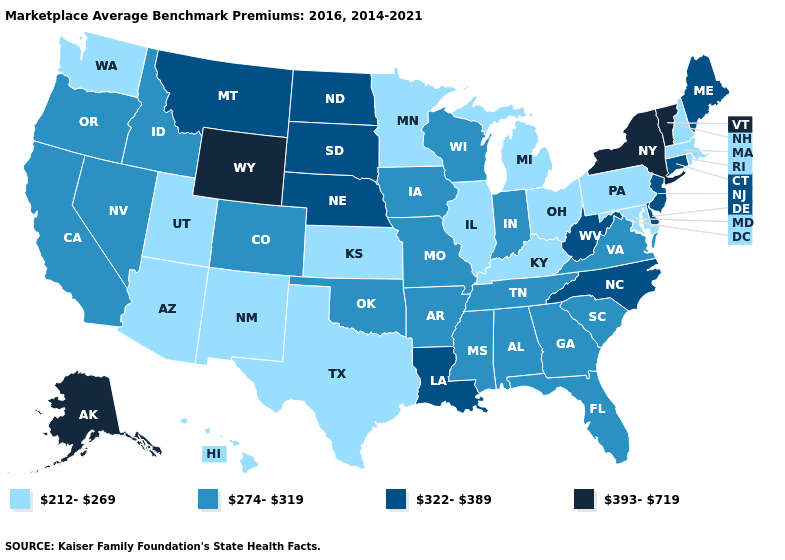Name the states that have a value in the range 212-269?
Keep it brief. Arizona, Hawaii, Illinois, Kansas, Kentucky, Maryland, Massachusetts, Michigan, Minnesota, New Hampshire, New Mexico, Ohio, Pennsylvania, Rhode Island, Texas, Utah, Washington. Among the states that border Utah , does Nevada have the lowest value?
Answer briefly. No. Does Alaska have the highest value in the USA?
Short answer required. Yes. Name the states that have a value in the range 393-719?
Write a very short answer. Alaska, New York, Vermont, Wyoming. How many symbols are there in the legend?
Answer briefly. 4. Which states have the highest value in the USA?
Answer briefly. Alaska, New York, Vermont, Wyoming. Name the states that have a value in the range 322-389?
Be succinct. Connecticut, Delaware, Louisiana, Maine, Montana, Nebraska, New Jersey, North Carolina, North Dakota, South Dakota, West Virginia. Name the states that have a value in the range 274-319?
Write a very short answer. Alabama, Arkansas, California, Colorado, Florida, Georgia, Idaho, Indiana, Iowa, Mississippi, Missouri, Nevada, Oklahoma, Oregon, South Carolina, Tennessee, Virginia, Wisconsin. Does Montana have a lower value than Wyoming?
Quick response, please. Yes. Among the states that border Indiana , which have the lowest value?
Keep it brief. Illinois, Kentucky, Michigan, Ohio. Name the states that have a value in the range 393-719?
Quick response, please. Alaska, New York, Vermont, Wyoming. Name the states that have a value in the range 212-269?
Quick response, please. Arizona, Hawaii, Illinois, Kansas, Kentucky, Maryland, Massachusetts, Michigan, Minnesota, New Hampshire, New Mexico, Ohio, Pennsylvania, Rhode Island, Texas, Utah, Washington. Which states have the highest value in the USA?
Concise answer only. Alaska, New York, Vermont, Wyoming. What is the value of Minnesota?
Write a very short answer. 212-269. Name the states that have a value in the range 393-719?
Concise answer only. Alaska, New York, Vermont, Wyoming. 